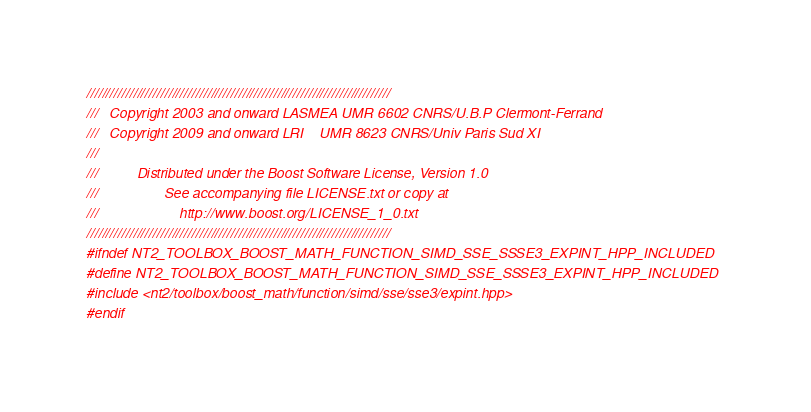<code> <loc_0><loc_0><loc_500><loc_500><_C++_>//////////////////////////////////////////////////////////////////////////////
///   Copyright 2003 and onward LASMEA UMR 6602 CNRS/U.B.P Clermont-Ferrand
///   Copyright 2009 and onward LRI    UMR 8623 CNRS/Univ Paris Sud XI
///
///          Distributed under the Boost Software License, Version 1.0
///                 See accompanying file LICENSE.txt or copy at
///                     http://www.boost.org/LICENSE_1_0.txt
//////////////////////////////////////////////////////////////////////////////
#ifndef NT2_TOOLBOX_BOOST_MATH_FUNCTION_SIMD_SSE_SSSE3_EXPINT_HPP_INCLUDED
#define NT2_TOOLBOX_BOOST_MATH_FUNCTION_SIMD_SSE_SSSE3_EXPINT_HPP_INCLUDED
#include <nt2/toolbox/boost_math/function/simd/sse/sse3/expint.hpp>
#endif
</code> 